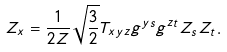Convert formula to latex. <formula><loc_0><loc_0><loc_500><loc_500>Z _ { x } = \frac { 1 } { 2 Z } \sqrt { \frac { 3 } { 2 } } T _ { x y z } g ^ { y s } g ^ { z t } Z _ { s } Z _ { t } .</formula> 